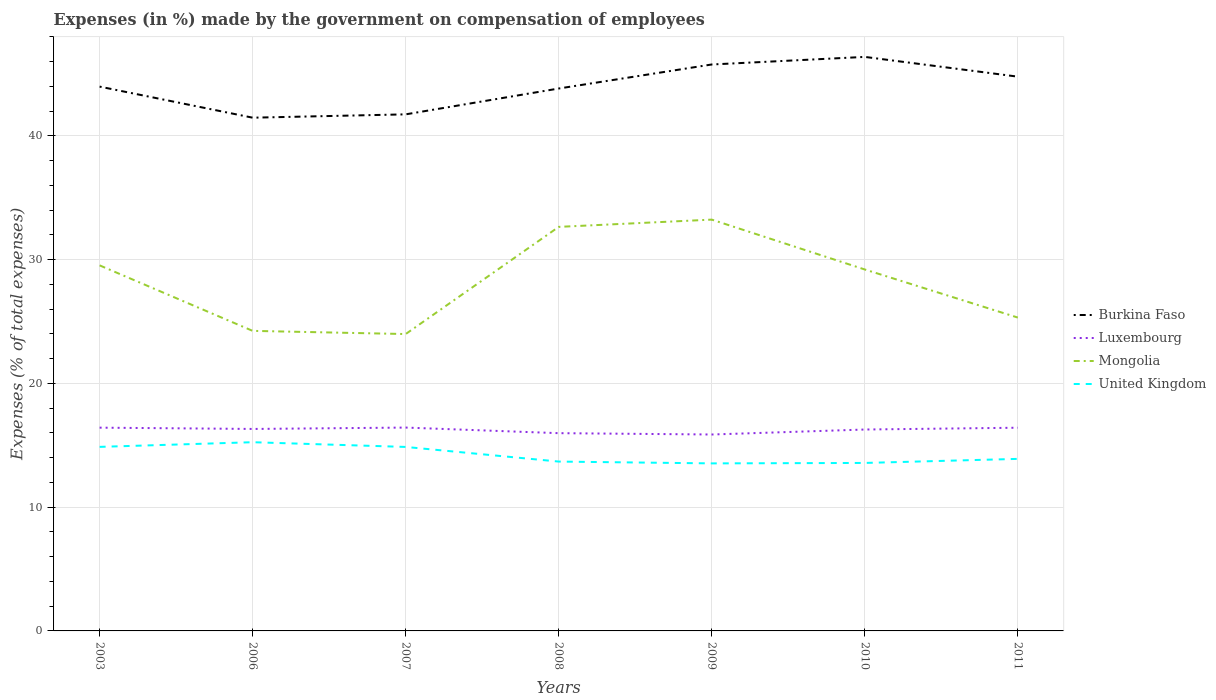How many different coloured lines are there?
Offer a terse response. 4. Across all years, what is the maximum percentage of expenses made by the government on compensation of employees in Burkina Faso?
Provide a short and direct response. 41.47. In which year was the percentage of expenses made by the government on compensation of employees in United Kingdom maximum?
Give a very brief answer. 2009. What is the total percentage of expenses made by the government on compensation of employees in Mongolia in the graph?
Your answer should be very brief. -8.66. What is the difference between the highest and the second highest percentage of expenses made by the government on compensation of employees in Luxembourg?
Your response must be concise. 0.56. What is the difference between the highest and the lowest percentage of expenses made by the government on compensation of employees in United Kingdom?
Provide a succinct answer. 3. Is the percentage of expenses made by the government on compensation of employees in Luxembourg strictly greater than the percentage of expenses made by the government on compensation of employees in Burkina Faso over the years?
Provide a succinct answer. Yes. How many lines are there?
Give a very brief answer. 4. Does the graph contain any zero values?
Provide a short and direct response. No. Where does the legend appear in the graph?
Your answer should be compact. Center right. How are the legend labels stacked?
Your response must be concise. Vertical. What is the title of the graph?
Make the answer very short. Expenses (in %) made by the government on compensation of employees. Does "Lesotho" appear as one of the legend labels in the graph?
Ensure brevity in your answer.  No. What is the label or title of the X-axis?
Your response must be concise. Years. What is the label or title of the Y-axis?
Your answer should be compact. Expenses (% of total expenses). What is the Expenses (% of total expenses) of Burkina Faso in 2003?
Make the answer very short. 43.98. What is the Expenses (% of total expenses) in Luxembourg in 2003?
Offer a very short reply. 16.42. What is the Expenses (% of total expenses) of Mongolia in 2003?
Ensure brevity in your answer.  29.54. What is the Expenses (% of total expenses) of United Kingdom in 2003?
Provide a succinct answer. 14.87. What is the Expenses (% of total expenses) of Burkina Faso in 2006?
Your response must be concise. 41.47. What is the Expenses (% of total expenses) of Luxembourg in 2006?
Make the answer very short. 16.32. What is the Expenses (% of total expenses) in Mongolia in 2006?
Your answer should be very brief. 24.25. What is the Expenses (% of total expenses) in United Kingdom in 2006?
Keep it short and to the point. 15.25. What is the Expenses (% of total expenses) in Burkina Faso in 2007?
Offer a very short reply. 41.74. What is the Expenses (% of total expenses) in Luxembourg in 2007?
Ensure brevity in your answer.  16.43. What is the Expenses (% of total expenses) in Mongolia in 2007?
Provide a short and direct response. 23.99. What is the Expenses (% of total expenses) in United Kingdom in 2007?
Offer a very short reply. 14.87. What is the Expenses (% of total expenses) of Burkina Faso in 2008?
Your answer should be compact. 43.83. What is the Expenses (% of total expenses) in Luxembourg in 2008?
Provide a succinct answer. 15.98. What is the Expenses (% of total expenses) in Mongolia in 2008?
Offer a very short reply. 32.65. What is the Expenses (% of total expenses) of United Kingdom in 2008?
Your answer should be very brief. 13.68. What is the Expenses (% of total expenses) in Burkina Faso in 2009?
Offer a terse response. 45.77. What is the Expenses (% of total expenses) in Luxembourg in 2009?
Your answer should be very brief. 15.87. What is the Expenses (% of total expenses) of Mongolia in 2009?
Your answer should be very brief. 33.24. What is the Expenses (% of total expenses) of United Kingdom in 2009?
Provide a short and direct response. 13.54. What is the Expenses (% of total expenses) in Burkina Faso in 2010?
Provide a short and direct response. 46.38. What is the Expenses (% of total expenses) of Luxembourg in 2010?
Your response must be concise. 16.27. What is the Expenses (% of total expenses) in Mongolia in 2010?
Offer a terse response. 29.21. What is the Expenses (% of total expenses) in United Kingdom in 2010?
Make the answer very short. 13.57. What is the Expenses (% of total expenses) of Burkina Faso in 2011?
Give a very brief answer. 44.79. What is the Expenses (% of total expenses) in Luxembourg in 2011?
Ensure brevity in your answer.  16.42. What is the Expenses (% of total expenses) in Mongolia in 2011?
Make the answer very short. 25.32. What is the Expenses (% of total expenses) in United Kingdom in 2011?
Give a very brief answer. 13.9. Across all years, what is the maximum Expenses (% of total expenses) of Burkina Faso?
Ensure brevity in your answer.  46.38. Across all years, what is the maximum Expenses (% of total expenses) of Luxembourg?
Keep it short and to the point. 16.43. Across all years, what is the maximum Expenses (% of total expenses) of Mongolia?
Your answer should be compact. 33.24. Across all years, what is the maximum Expenses (% of total expenses) in United Kingdom?
Keep it short and to the point. 15.25. Across all years, what is the minimum Expenses (% of total expenses) of Burkina Faso?
Your response must be concise. 41.47. Across all years, what is the minimum Expenses (% of total expenses) of Luxembourg?
Your answer should be very brief. 15.87. Across all years, what is the minimum Expenses (% of total expenses) in Mongolia?
Your response must be concise. 23.99. Across all years, what is the minimum Expenses (% of total expenses) of United Kingdom?
Offer a very short reply. 13.54. What is the total Expenses (% of total expenses) in Burkina Faso in the graph?
Make the answer very short. 307.97. What is the total Expenses (% of total expenses) of Luxembourg in the graph?
Ensure brevity in your answer.  113.72. What is the total Expenses (% of total expenses) in Mongolia in the graph?
Give a very brief answer. 198.19. What is the total Expenses (% of total expenses) in United Kingdom in the graph?
Make the answer very short. 99.69. What is the difference between the Expenses (% of total expenses) in Burkina Faso in 2003 and that in 2006?
Provide a succinct answer. 2.51. What is the difference between the Expenses (% of total expenses) in Luxembourg in 2003 and that in 2006?
Offer a very short reply. 0.1. What is the difference between the Expenses (% of total expenses) of Mongolia in 2003 and that in 2006?
Offer a very short reply. 5.29. What is the difference between the Expenses (% of total expenses) in United Kingdom in 2003 and that in 2006?
Make the answer very short. -0.38. What is the difference between the Expenses (% of total expenses) of Burkina Faso in 2003 and that in 2007?
Your answer should be very brief. 2.24. What is the difference between the Expenses (% of total expenses) in Luxembourg in 2003 and that in 2007?
Offer a terse response. -0.01. What is the difference between the Expenses (% of total expenses) in Mongolia in 2003 and that in 2007?
Give a very brief answer. 5.55. What is the difference between the Expenses (% of total expenses) in United Kingdom in 2003 and that in 2007?
Your answer should be compact. 0.01. What is the difference between the Expenses (% of total expenses) of Burkina Faso in 2003 and that in 2008?
Your answer should be very brief. 0.15. What is the difference between the Expenses (% of total expenses) in Luxembourg in 2003 and that in 2008?
Your answer should be compact. 0.45. What is the difference between the Expenses (% of total expenses) of Mongolia in 2003 and that in 2008?
Provide a succinct answer. -3.11. What is the difference between the Expenses (% of total expenses) in United Kingdom in 2003 and that in 2008?
Provide a short and direct response. 1.19. What is the difference between the Expenses (% of total expenses) in Burkina Faso in 2003 and that in 2009?
Provide a short and direct response. -1.79. What is the difference between the Expenses (% of total expenses) in Luxembourg in 2003 and that in 2009?
Offer a very short reply. 0.55. What is the difference between the Expenses (% of total expenses) in Mongolia in 2003 and that in 2009?
Your answer should be compact. -3.7. What is the difference between the Expenses (% of total expenses) in United Kingdom in 2003 and that in 2009?
Your answer should be very brief. 1.33. What is the difference between the Expenses (% of total expenses) of Burkina Faso in 2003 and that in 2010?
Your response must be concise. -2.4. What is the difference between the Expenses (% of total expenses) of Luxembourg in 2003 and that in 2010?
Provide a short and direct response. 0.15. What is the difference between the Expenses (% of total expenses) of Mongolia in 2003 and that in 2010?
Give a very brief answer. 0.33. What is the difference between the Expenses (% of total expenses) of United Kingdom in 2003 and that in 2010?
Make the answer very short. 1.3. What is the difference between the Expenses (% of total expenses) of Burkina Faso in 2003 and that in 2011?
Your answer should be compact. -0.8. What is the difference between the Expenses (% of total expenses) of Luxembourg in 2003 and that in 2011?
Your answer should be compact. 0. What is the difference between the Expenses (% of total expenses) of Mongolia in 2003 and that in 2011?
Keep it short and to the point. 4.22. What is the difference between the Expenses (% of total expenses) of United Kingdom in 2003 and that in 2011?
Ensure brevity in your answer.  0.97. What is the difference between the Expenses (% of total expenses) of Burkina Faso in 2006 and that in 2007?
Keep it short and to the point. -0.27. What is the difference between the Expenses (% of total expenses) in Luxembourg in 2006 and that in 2007?
Offer a terse response. -0.11. What is the difference between the Expenses (% of total expenses) of Mongolia in 2006 and that in 2007?
Ensure brevity in your answer.  0.26. What is the difference between the Expenses (% of total expenses) in United Kingdom in 2006 and that in 2007?
Keep it short and to the point. 0.38. What is the difference between the Expenses (% of total expenses) of Burkina Faso in 2006 and that in 2008?
Offer a terse response. -2.36. What is the difference between the Expenses (% of total expenses) of Luxembourg in 2006 and that in 2008?
Provide a short and direct response. 0.34. What is the difference between the Expenses (% of total expenses) of Mongolia in 2006 and that in 2008?
Keep it short and to the point. -8.4. What is the difference between the Expenses (% of total expenses) of United Kingdom in 2006 and that in 2008?
Offer a terse response. 1.56. What is the difference between the Expenses (% of total expenses) of Burkina Faso in 2006 and that in 2009?
Your response must be concise. -4.3. What is the difference between the Expenses (% of total expenses) in Luxembourg in 2006 and that in 2009?
Offer a terse response. 0.45. What is the difference between the Expenses (% of total expenses) of Mongolia in 2006 and that in 2009?
Make the answer very short. -8.99. What is the difference between the Expenses (% of total expenses) in United Kingdom in 2006 and that in 2009?
Provide a succinct answer. 1.71. What is the difference between the Expenses (% of total expenses) in Burkina Faso in 2006 and that in 2010?
Your answer should be very brief. -4.91. What is the difference between the Expenses (% of total expenses) of Luxembourg in 2006 and that in 2010?
Your answer should be very brief. 0.05. What is the difference between the Expenses (% of total expenses) of Mongolia in 2006 and that in 2010?
Keep it short and to the point. -4.96. What is the difference between the Expenses (% of total expenses) in United Kingdom in 2006 and that in 2010?
Your answer should be very brief. 1.67. What is the difference between the Expenses (% of total expenses) of Burkina Faso in 2006 and that in 2011?
Ensure brevity in your answer.  -3.32. What is the difference between the Expenses (% of total expenses) in Luxembourg in 2006 and that in 2011?
Your answer should be compact. -0.1. What is the difference between the Expenses (% of total expenses) in Mongolia in 2006 and that in 2011?
Keep it short and to the point. -1.07. What is the difference between the Expenses (% of total expenses) in United Kingdom in 2006 and that in 2011?
Ensure brevity in your answer.  1.35. What is the difference between the Expenses (% of total expenses) of Burkina Faso in 2007 and that in 2008?
Your response must be concise. -2.09. What is the difference between the Expenses (% of total expenses) of Luxembourg in 2007 and that in 2008?
Make the answer very short. 0.45. What is the difference between the Expenses (% of total expenses) in Mongolia in 2007 and that in 2008?
Provide a succinct answer. -8.66. What is the difference between the Expenses (% of total expenses) in United Kingdom in 2007 and that in 2008?
Provide a short and direct response. 1.18. What is the difference between the Expenses (% of total expenses) of Burkina Faso in 2007 and that in 2009?
Make the answer very short. -4.03. What is the difference between the Expenses (% of total expenses) of Luxembourg in 2007 and that in 2009?
Your answer should be very brief. 0.56. What is the difference between the Expenses (% of total expenses) in Mongolia in 2007 and that in 2009?
Make the answer very short. -9.25. What is the difference between the Expenses (% of total expenses) in United Kingdom in 2007 and that in 2009?
Offer a very short reply. 1.33. What is the difference between the Expenses (% of total expenses) in Burkina Faso in 2007 and that in 2010?
Your answer should be very brief. -4.64. What is the difference between the Expenses (% of total expenses) of Luxembourg in 2007 and that in 2010?
Your answer should be very brief. 0.16. What is the difference between the Expenses (% of total expenses) of Mongolia in 2007 and that in 2010?
Your response must be concise. -5.22. What is the difference between the Expenses (% of total expenses) of United Kingdom in 2007 and that in 2010?
Provide a succinct answer. 1.29. What is the difference between the Expenses (% of total expenses) of Burkina Faso in 2007 and that in 2011?
Your answer should be compact. -3.05. What is the difference between the Expenses (% of total expenses) of Luxembourg in 2007 and that in 2011?
Your response must be concise. 0.01. What is the difference between the Expenses (% of total expenses) in Mongolia in 2007 and that in 2011?
Keep it short and to the point. -1.33. What is the difference between the Expenses (% of total expenses) in United Kingdom in 2007 and that in 2011?
Your response must be concise. 0.97. What is the difference between the Expenses (% of total expenses) in Burkina Faso in 2008 and that in 2009?
Give a very brief answer. -1.94. What is the difference between the Expenses (% of total expenses) of Luxembourg in 2008 and that in 2009?
Ensure brevity in your answer.  0.11. What is the difference between the Expenses (% of total expenses) of Mongolia in 2008 and that in 2009?
Offer a very short reply. -0.59. What is the difference between the Expenses (% of total expenses) of United Kingdom in 2008 and that in 2009?
Ensure brevity in your answer.  0.15. What is the difference between the Expenses (% of total expenses) of Burkina Faso in 2008 and that in 2010?
Give a very brief answer. -2.55. What is the difference between the Expenses (% of total expenses) of Luxembourg in 2008 and that in 2010?
Give a very brief answer. -0.29. What is the difference between the Expenses (% of total expenses) in Mongolia in 2008 and that in 2010?
Your response must be concise. 3.44. What is the difference between the Expenses (% of total expenses) of United Kingdom in 2008 and that in 2010?
Keep it short and to the point. 0.11. What is the difference between the Expenses (% of total expenses) in Burkina Faso in 2008 and that in 2011?
Your answer should be compact. -0.96. What is the difference between the Expenses (% of total expenses) in Luxembourg in 2008 and that in 2011?
Your answer should be very brief. -0.44. What is the difference between the Expenses (% of total expenses) in Mongolia in 2008 and that in 2011?
Ensure brevity in your answer.  7.33. What is the difference between the Expenses (% of total expenses) in United Kingdom in 2008 and that in 2011?
Ensure brevity in your answer.  -0.22. What is the difference between the Expenses (% of total expenses) of Burkina Faso in 2009 and that in 2010?
Provide a succinct answer. -0.61. What is the difference between the Expenses (% of total expenses) in Luxembourg in 2009 and that in 2010?
Offer a very short reply. -0.4. What is the difference between the Expenses (% of total expenses) in Mongolia in 2009 and that in 2010?
Your answer should be very brief. 4.03. What is the difference between the Expenses (% of total expenses) in United Kingdom in 2009 and that in 2010?
Provide a short and direct response. -0.04. What is the difference between the Expenses (% of total expenses) in Burkina Faso in 2009 and that in 2011?
Give a very brief answer. 0.98. What is the difference between the Expenses (% of total expenses) in Luxembourg in 2009 and that in 2011?
Your answer should be compact. -0.55. What is the difference between the Expenses (% of total expenses) of Mongolia in 2009 and that in 2011?
Your answer should be compact. 7.92. What is the difference between the Expenses (% of total expenses) in United Kingdom in 2009 and that in 2011?
Make the answer very short. -0.36. What is the difference between the Expenses (% of total expenses) in Burkina Faso in 2010 and that in 2011?
Offer a terse response. 1.6. What is the difference between the Expenses (% of total expenses) in Luxembourg in 2010 and that in 2011?
Give a very brief answer. -0.15. What is the difference between the Expenses (% of total expenses) in Mongolia in 2010 and that in 2011?
Your answer should be compact. 3.89. What is the difference between the Expenses (% of total expenses) in United Kingdom in 2010 and that in 2011?
Provide a short and direct response. -0.33. What is the difference between the Expenses (% of total expenses) in Burkina Faso in 2003 and the Expenses (% of total expenses) in Luxembourg in 2006?
Provide a succinct answer. 27.66. What is the difference between the Expenses (% of total expenses) in Burkina Faso in 2003 and the Expenses (% of total expenses) in Mongolia in 2006?
Provide a succinct answer. 19.74. What is the difference between the Expenses (% of total expenses) of Burkina Faso in 2003 and the Expenses (% of total expenses) of United Kingdom in 2006?
Ensure brevity in your answer.  28.74. What is the difference between the Expenses (% of total expenses) of Luxembourg in 2003 and the Expenses (% of total expenses) of Mongolia in 2006?
Make the answer very short. -7.82. What is the difference between the Expenses (% of total expenses) in Luxembourg in 2003 and the Expenses (% of total expenses) in United Kingdom in 2006?
Give a very brief answer. 1.18. What is the difference between the Expenses (% of total expenses) in Mongolia in 2003 and the Expenses (% of total expenses) in United Kingdom in 2006?
Offer a terse response. 14.29. What is the difference between the Expenses (% of total expenses) of Burkina Faso in 2003 and the Expenses (% of total expenses) of Luxembourg in 2007?
Offer a very short reply. 27.55. What is the difference between the Expenses (% of total expenses) of Burkina Faso in 2003 and the Expenses (% of total expenses) of Mongolia in 2007?
Your answer should be very brief. 19.99. What is the difference between the Expenses (% of total expenses) in Burkina Faso in 2003 and the Expenses (% of total expenses) in United Kingdom in 2007?
Offer a terse response. 29.12. What is the difference between the Expenses (% of total expenses) in Luxembourg in 2003 and the Expenses (% of total expenses) in Mongolia in 2007?
Make the answer very short. -7.56. What is the difference between the Expenses (% of total expenses) of Luxembourg in 2003 and the Expenses (% of total expenses) of United Kingdom in 2007?
Offer a terse response. 1.56. What is the difference between the Expenses (% of total expenses) in Mongolia in 2003 and the Expenses (% of total expenses) in United Kingdom in 2007?
Your answer should be very brief. 14.67. What is the difference between the Expenses (% of total expenses) in Burkina Faso in 2003 and the Expenses (% of total expenses) in Luxembourg in 2008?
Make the answer very short. 28. What is the difference between the Expenses (% of total expenses) in Burkina Faso in 2003 and the Expenses (% of total expenses) in Mongolia in 2008?
Give a very brief answer. 11.33. What is the difference between the Expenses (% of total expenses) of Burkina Faso in 2003 and the Expenses (% of total expenses) of United Kingdom in 2008?
Ensure brevity in your answer.  30.3. What is the difference between the Expenses (% of total expenses) in Luxembourg in 2003 and the Expenses (% of total expenses) in Mongolia in 2008?
Provide a succinct answer. -16.22. What is the difference between the Expenses (% of total expenses) of Luxembourg in 2003 and the Expenses (% of total expenses) of United Kingdom in 2008?
Offer a terse response. 2.74. What is the difference between the Expenses (% of total expenses) of Mongolia in 2003 and the Expenses (% of total expenses) of United Kingdom in 2008?
Provide a succinct answer. 15.85. What is the difference between the Expenses (% of total expenses) of Burkina Faso in 2003 and the Expenses (% of total expenses) of Luxembourg in 2009?
Provide a short and direct response. 28.11. What is the difference between the Expenses (% of total expenses) in Burkina Faso in 2003 and the Expenses (% of total expenses) in Mongolia in 2009?
Give a very brief answer. 10.75. What is the difference between the Expenses (% of total expenses) of Burkina Faso in 2003 and the Expenses (% of total expenses) of United Kingdom in 2009?
Make the answer very short. 30.45. What is the difference between the Expenses (% of total expenses) in Luxembourg in 2003 and the Expenses (% of total expenses) in Mongolia in 2009?
Provide a succinct answer. -16.81. What is the difference between the Expenses (% of total expenses) of Luxembourg in 2003 and the Expenses (% of total expenses) of United Kingdom in 2009?
Provide a short and direct response. 2.89. What is the difference between the Expenses (% of total expenses) in Mongolia in 2003 and the Expenses (% of total expenses) in United Kingdom in 2009?
Ensure brevity in your answer.  16. What is the difference between the Expenses (% of total expenses) in Burkina Faso in 2003 and the Expenses (% of total expenses) in Luxembourg in 2010?
Your response must be concise. 27.71. What is the difference between the Expenses (% of total expenses) of Burkina Faso in 2003 and the Expenses (% of total expenses) of Mongolia in 2010?
Make the answer very short. 14.78. What is the difference between the Expenses (% of total expenses) of Burkina Faso in 2003 and the Expenses (% of total expenses) of United Kingdom in 2010?
Your response must be concise. 30.41. What is the difference between the Expenses (% of total expenses) in Luxembourg in 2003 and the Expenses (% of total expenses) in Mongolia in 2010?
Provide a short and direct response. -12.78. What is the difference between the Expenses (% of total expenses) in Luxembourg in 2003 and the Expenses (% of total expenses) in United Kingdom in 2010?
Your answer should be very brief. 2.85. What is the difference between the Expenses (% of total expenses) in Mongolia in 2003 and the Expenses (% of total expenses) in United Kingdom in 2010?
Provide a short and direct response. 15.97. What is the difference between the Expenses (% of total expenses) of Burkina Faso in 2003 and the Expenses (% of total expenses) of Luxembourg in 2011?
Your response must be concise. 27.56. What is the difference between the Expenses (% of total expenses) in Burkina Faso in 2003 and the Expenses (% of total expenses) in Mongolia in 2011?
Offer a very short reply. 18.66. What is the difference between the Expenses (% of total expenses) in Burkina Faso in 2003 and the Expenses (% of total expenses) in United Kingdom in 2011?
Offer a very short reply. 30.08. What is the difference between the Expenses (% of total expenses) of Luxembourg in 2003 and the Expenses (% of total expenses) of Mongolia in 2011?
Offer a terse response. -8.9. What is the difference between the Expenses (% of total expenses) of Luxembourg in 2003 and the Expenses (% of total expenses) of United Kingdom in 2011?
Your response must be concise. 2.52. What is the difference between the Expenses (% of total expenses) of Mongolia in 2003 and the Expenses (% of total expenses) of United Kingdom in 2011?
Your answer should be compact. 15.64. What is the difference between the Expenses (% of total expenses) of Burkina Faso in 2006 and the Expenses (% of total expenses) of Luxembourg in 2007?
Ensure brevity in your answer.  25.04. What is the difference between the Expenses (% of total expenses) of Burkina Faso in 2006 and the Expenses (% of total expenses) of Mongolia in 2007?
Make the answer very short. 17.48. What is the difference between the Expenses (% of total expenses) of Burkina Faso in 2006 and the Expenses (% of total expenses) of United Kingdom in 2007?
Offer a very short reply. 26.61. What is the difference between the Expenses (% of total expenses) in Luxembourg in 2006 and the Expenses (% of total expenses) in Mongolia in 2007?
Provide a succinct answer. -7.67. What is the difference between the Expenses (% of total expenses) in Luxembourg in 2006 and the Expenses (% of total expenses) in United Kingdom in 2007?
Offer a terse response. 1.45. What is the difference between the Expenses (% of total expenses) of Mongolia in 2006 and the Expenses (% of total expenses) of United Kingdom in 2007?
Give a very brief answer. 9.38. What is the difference between the Expenses (% of total expenses) in Burkina Faso in 2006 and the Expenses (% of total expenses) in Luxembourg in 2008?
Your response must be concise. 25.49. What is the difference between the Expenses (% of total expenses) in Burkina Faso in 2006 and the Expenses (% of total expenses) in Mongolia in 2008?
Offer a very short reply. 8.82. What is the difference between the Expenses (% of total expenses) of Burkina Faso in 2006 and the Expenses (% of total expenses) of United Kingdom in 2008?
Offer a very short reply. 27.79. What is the difference between the Expenses (% of total expenses) in Luxembourg in 2006 and the Expenses (% of total expenses) in Mongolia in 2008?
Provide a short and direct response. -16.33. What is the difference between the Expenses (% of total expenses) of Luxembourg in 2006 and the Expenses (% of total expenses) of United Kingdom in 2008?
Keep it short and to the point. 2.64. What is the difference between the Expenses (% of total expenses) of Mongolia in 2006 and the Expenses (% of total expenses) of United Kingdom in 2008?
Your answer should be compact. 10.56. What is the difference between the Expenses (% of total expenses) in Burkina Faso in 2006 and the Expenses (% of total expenses) in Luxembourg in 2009?
Make the answer very short. 25.6. What is the difference between the Expenses (% of total expenses) in Burkina Faso in 2006 and the Expenses (% of total expenses) in Mongolia in 2009?
Your answer should be very brief. 8.24. What is the difference between the Expenses (% of total expenses) of Burkina Faso in 2006 and the Expenses (% of total expenses) of United Kingdom in 2009?
Offer a terse response. 27.93. What is the difference between the Expenses (% of total expenses) in Luxembourg in 2006 and the Expenses (% of total expenses) in Mongolia in 2009?
Provide a short and direct response. -16.92. What is the difference between the Expenses (% of total expenses) in Luxembourg in 2006 and the Expenses (% of total expenses) in United Kingdom in 2009?
Provide a short and direct response. 2.78. What is the difference between the Expenses (% of total expenses) of Mongolia in 2006 and the Expenses (% of total expenses) of United Kingdom in 2009?
Your answer should be very brief. 10.71. What is the difference between the Expenses (% of total expenses) in Burkina Faso in 2006 and the Expenses (% of total expenses) in Luxembourg in 2010?
Offer a very short reply. 25.2. What is the difference between the Expenses (% of total expenses) of Burkina Faso in 2006 and the Expenses (% of total expenses) of Mongolia in 2010?
Provide a short and direct response. 12.27. What is the difference between the Expenses (% of total expenses) in Burkina Faso in 2006 and the Expenses (% of total expenses) in United Kingdom in 2010?
Keep it short and to the point. 27.9. What is the difference between the Expenses (% of total expenses) of Luxembourg in 2006 and the Expenses (% of total expenses) of Mongolia in 2010?
Give a very brief answer. -12.89. What is the difference between the Expenses (% of total expenses) of Luxembourg in 2006 and the Expenses (% of total expenses) of United Kingdom in 2010?
Your answer should be compact. 2.75. What is the difference between the Expenses (% of total expenses) in Mongolia in 2006 and the Expenses (% of total expenses) in United Kingdom in 2010?
Keep it short and to the point. 10.67. What is the difference between the Expenses (% of total expenses) in Burkina Faso in 2006 and the Expenses (% of total expenses) in Luxembourg in 2011?
Your answer should be very brief. 25.05. What is the difference between the Expenses (% of total expenses) in Burkina Faso in 2006 and the Expenses (% of total expenses) in Mongolia in 2011?
Provide a short and direct response. 16.15. What is the difference between the Expenses (% of total expenses) of Burkina Faso in 2006 and the Expenses (% of total expenses) of United Kingdom in 2011?
Give a very brief answer. 27.57. What is the difference between the Expenses (% of total expenses) of Luxembourg in 2006 and the Expenses (% of total expenses) of Mongolia in 2011?
Your response must be concise. -9. What is the difference between the Expenses (% of total expenses) of Luxembourg in 2006 and the Expenses (% of total expenses) of United Kingdom in 2011?
Give a very brief answer. 2.42. What is the difference between the Expenses (% of total expenses) in Mongolia in 2006 and the Expenses (% of total expenses) in United Kingdom in 2011?
Make the answer very short. 10.34. What is the difference between the Expenses (% of total expenses) of Burkina Faso in 2007 and the Expenses (% of total expenses) of Luxembourg in 2008?
Your response must be concise. 25.76. What is the difference between the Expenses (% of total expenses) in Burkina Faso in 2007 and the Expenses (% of total expenses) in Mongolia in 2008?
Your answer should be compact. 9.09. What is the difference between the Expenses (% of total expenses) of Burkina Faso in 2007 and the Expenses (% of total expenses) of United Kingdom in 2008?
Your answer should be very brief. 28.06. What is the difference between the Expenses (% of total expenses) in Luxembourg in 2007 and the Expenses (% of total expenses) in Mongolia in 2008?
Give a very brief answer. -16.22. What is the difference between the Expenses (% of total expenses) in Luxembourg in 2007 and the Expenses (% of total expenses) in United Kingdom in 2008?
Your response must be concise. 2.75. What is the difference between the Expenses (% of total expenses) in Mongolia in 2007 and the Expenses (% of total expenses) in United Kingdom in 2008?
Your answer should be compact. 10.3. What is the difference between the Expenses (% of total expenses) in Burkina Faso in 2007 and the Expenses (% of total expenses) in Luxembourg in 2009?
Ensure brevity in your answer.  25.87. What is the difference between the Expenses (% of total expenses) in Burkina Faso in 2007 and the Expenses (% of total expenses) in Mongolia in 2009?
Offer a very short reply. 8.51. What is the difference between the Expenses (% of total expenses) in Burkina Faso in 2007 and the Expenses (% of total expenses) in United Kingdom in 2009?
Your response must be concise. 28.2. What is the difference between the Expenses (% of total expenses) in Luxembourg in 2007 and the Expenses (% of total expenses) in Mongolia in 2009?
Your answer should be very brief. -16.8. What is the difference between the Expenses (% of total expenses) of Luxembourg in 2007 and the Expenses (% of total expenses) of United Kingdom in 2009?
Offer a very short reply. 2.89. What is the difference between the Expenses (% of total expenses) in Mongolia in 2007 and the Expenses (% of total expenses) in United Kingdom in 2009?
Give a very brief answer. 10.45. What is the difference between the Expenses (% of total expenses) of Burkina Faso in 2007 and the Expenses (% of total expenses) of Luxembourg in 2010?
Offer a terse response. 25.47. What is the difference between the Expenses (% of total expenses) in Burkina Faso in 2007 and the Expenses (% of total expenses) in Mongolia in 2010?
Your answer should be very brief. 12.54. What is the difference between the Expenses (% of total expenses) in Burkina Faso in 2007 and the Expenses (% of total expenses) in United Kingdom in 2010?
Ensure brevity in your answer.  28.17. What is the difference between the Expenses (% of total expenses) in Luxembourg in 2007 and the Expenses (% of total expenses) in Mongolia in 2010?
Ensure brevity in your answer.  -12.77. What is the difference between the Expenses (% of total expenses) in Luxembourg in 2007 and the Expenses (% of total expenses) in United Kingdom in 2010?
Give a very brief answer. 2.86. What is the difference between the Expenses (% of total expenses) of Mongolia in 2007 and the Expenses (% of total expenses) of United Kingdom in 2010?
Give a very brief answer. 10.42. What is the difference between the Expenses (% of total expenses) of Burkina Faso in 2007 and the Expenses (% of total expenses) of Luxembourg in 2011?
Ensure brevity in your answer.  25.32. What is the difference between the Expenses (% of total expenses) in Burkina Faso in 2007 and the Expenses (% of total expenses) in Mongolia in 2011?
Your answer should be very brief. 16.42. What is the difference between the Expenses (% of total expenses) of Burkina Faso in 2007 and the Expenses (% of total expenses) of United Kingdom in 2011?
Your answer should be very brief. 27.84. What is the difference between the Expenses (% of total expenses) of Luxembourg in 2007 and the Expenses (% of total expenses) of Mongolia in 2011?
Make the answer very short. -8.89. What is the difference between the Expenses (% of total expenses) in Luxembourg in 2007 and the Expenses (% of total expenses) in United Kingdom in 2011?
Offer a terse response. 2.53. What is the difference between the Expenses (% of total expenses) in Mongolia in 2007 and the Expenses (% of total expenses) in United Kingdom in 2011?
Your response must be concise. 10.09. What is the difference between the Expenses (% of total expenses) in Burkina Faso in 2008 and the Expenses (% of total expenses) in Luxembourg in 2009?
Offer a very short reply. 27.96. What is the difference between the Expenses (% of total expenses) of Burkina Faso in 2008 and the Expenses (% of total expenses) of Mongolia in 2009?
Give a very brief answer. 10.59. What is the difference between the Expenses (% of total expenses) of Burkina Faso in 2008 and the Expenses (% of total expenses) of United Kingdom in 2009?
Offer a very short reply. 30.29. What is the difference between the Expenses (% of total expenses) in Luxembourg in 2008 and the Expenses (% of total expenses) in Mongolia in 2009?
Keep it short and to the point. -17.26. What is the difference between the Expenses (% of total expenses) in Luxembourg in 2008 and the Expenses (% of total expenses) in United Kingdom in 2009?
Your answer should be compact. 2.44. What is the difference between the Expenses (% of total expenses) in Mongolia in 2008 and the Expenses (% of total expenses) in United Kingdom in 2009?
Offer a terse response. 19.11. What is the difference between the Expenses (% of total expenses) of Burkina Faso in 2008 and the Expenses (% of total expenses) of Luxembourg in 2010?
Provide a short and direct response. 27.56. What is the difference between the Expenses (% of total expenses) of Burkina Faso in 2008 and the Expenses (% of total expenses) of Mongolia in 2010?
Keep it short and to the point. 14.62. What is the difference between the Expenses (% of total expenses) of Burkina Faso in 2008 and the Expenses (% of total expenses) of United Kingdom in 2010?
Make the answer very short. 30.26. What is the difference between the Expenses (% of total expenses) in Luxembourg in 2008 and the Expenses (% of total expenses) in Mongolia in 2010?
Make the answer very short. -13.23. What is the difference between the Expenses (% of total expenses) in Luxembourg in 2008 and the Expenses (% of total expenses) in United Kingdom in 2010?
Your answer should be very brief. 2.41. What is the difference between the Expenses (% of total expenses) in Mongolia in 2008 and the Expenses (% of total expenses) in United Kingdom in 2010?
Ensure brevity in your answer.  19.08. What is the difference between the Expenses (% of total expenses) of Burkina Faso in 2008 and the Expenses (% of total expenses) of Luxembourg in 2011?
Give a very brief answer. 27.41. What is the difference between the Expenses (% of total expenses) in Burkina Faso in 2008 and the Expenses (% of total expenses) in Mongolia in 2011?
Ensure brevity in your answer.  18.51. What is the difference between the Expenses (% of total expenses) in Burkina Faso in 2008 and the Expenses (% of total expenses) in United Kingdom in 2011?
Your response must be concise. 29.93. What is the difference between the Expenses (% of total expenses) of Luxembourg in 2008 and the Expenses (% of total expenses) of Mongolia in 2011?
Your answer should be compact. -9.34. What is the difference between the Expenses (% of total expenses) in Luxembourg in 2008 and the Expenses (% of total expenses) in United Kingdom in 2011?
Your response must be concise. 2.08. What is the difference between the Expenses (% of total expenses) in Mongolia in 2008 and the Expenses (% of total expenses) in United Kingdom in 2011?
Keep it short and to the point. 18.75. What is the difference between the Expenses (% of total expenses) in Burkina Faso in 2009 and the Expenses (% of total expenses) in Luxembourg in 2010?
Make the answer very short. 29.5. What is the difference between the Expenses (% of total expenses) of Burkina Faso in 2009 and the Expenses (% of total expenses) of Mongolia in 2010?
Your response must be concise. 16.57. What is the difference between the Expenses (% of total expenses) in Burkina Faso in 2009 and the Expenses (% of total expenses) in United Kingdom in 2010?
Make the answer very short. 32.2. What is the difference between the Expenses (% of total expenses) in Luxembourg in 2009 and the Expenses (% of total expenses) in Mongolia in 2010?
Your answer should be compact. -13.33. What is the difference between the Expenses (% of total expenses) in Luxembourg in 2009 and the Expenses (% of total expenses) in United Kingdom in 2010?
Ensure brevity in your answer.  2.3. What is the difference between the Expenses (% of total expenses) in Mongolia in 2009 and the Expenses (% of total expenses) in United Kingdom in 2010?
Offer a very short reply. 19.66. What is the difference between the Expenses (% of total expenses) in Burkina Faso in 2009 and the Expenses (% of total expenses) in Luxembourg in 2011?
Make the answer very short. 29.35. What is the difference between the Expenses (% of total expenses) of Burkina Faso in 2009 and the Expenses (% of total expenses) of Mongolia in 2011?
Offer a terse response. 20.45. What is the difference between the Expenses (% of total expenses) of Burkina Faso in 2009 and the Expenses (% of total expenses) of United Kingdom in 2011?
Your answer should be very brief. 31.87. What is the difference between the Expenses (% of total expenses) in Luxembourg in 2009 and the Expenses (% of total expenses) in Mongolia in 2011?
Offer a terse response. -9.45. What is the difference between the Expenses (% of total expenses) in Luxembourg in 2009 and the Expenses (% of total expenses) in United Kingdom in 2011?
Offer a very short reply. 1.97. What is the difference between the Expenses (% of total expenses) in Mongolia in 2009 and the Expenses (% of total expenses) in United Kingdom in 2011?
Give a very brief answer. 19.33. What is the difference between the Expenses (% of total expenses) in Burkina Faso in 2010 and the Expenses (% of total expenses) in Luxembourg in 2011?
Your response must be concise. 29.96. What is the difference between the Expenses (% of total expenses) in Burkina Faso in 2010 and the Expenses (% of total expenses) in Mongolia in 2011?
Give a very brief answer. 21.06. What is the difference between the Expenses (% of total expenses) of Burkina Faso in 2010 and the Expenses (% of total expenses) of United Kingdom in 2011?
Offer a terse response. 32.48. What is the difference between the Expenses (% of total expenses) of Luxembourg in 2010 and the Expenses (% of total expenses) of Mongolia in 2011?
Keep it short and to the point. -9.05. What is the difference between the Expenses (% of total expenses) of Luxembourg in 2010 and the Expenses (% of total expenses) of United Kingdom in 2011?
Provide a succinct answer. 2.37. What is the difference between the Expenses (% of total expenses) in Mongolia in 2010 and the Expenses (% of total expenses) in United Kingdom in 2011?
Your answer should be compact. 15.3. What is the average Expenses (% of total expenses) of Burkina Faso per year?
Provide a succinct answer. 44. What is the average Expenses (% of total expenses) of Luxembourg per year?
Your answer should be compact. 16.25. What is the average Expenses (% of total expenses) of Mongolia per year?
Your answer should be very brief. 28.31. What is the average Expenses (% of total expenses) in United Kingdom per year?
Offer a very short reply. 14.24. In the year 2003, what is the difference between the Expenses (% of total expenses) of Burkina Faso and Expenses (% of total expenses) of Luxembourg?
Provide a short and direct response. 27.56. In the year 2003, what is the difference between the Expenses (% of total expenses) of Burkina Faso and Expenses (% of total expenses) of Mongolia?
Make the answer very short. 14.44. In the year 2003, what is the difference between the Expenses (% of total expenses) in Burkina Faso and Expenses (% of total expenses) in United Kingdom?
Provide a short and direct response. 29.11. In the year 2003, what is the difference between the Expenses (% of total expenses) in Luxembourg and Expenses (% of total expenses) in Mongolia?
Provide a succinct answer. -13.11. In the year 2003, what is the difference between the Expenses (% of total expenses) in Luxembourg and Expenses (% of total expenses) in United Kingdom?
Your answer should be compact. 1.55. In the year 2003, what is the difference between the Expenses (% of total expenses) of Mongolia and Expenses (% of total expenses) of United Kingdom?
Your response must be concise. 14.67. In the year 2006, what is the difference between the Expenses (% of total expenses) of Burkina Faso and Expenses (% of total expenses) of Luxembourg?
Offer a very short reply. 25.15. In the year 2006, what is the difference between the Expenses (% of total expenses) in Burkina Faso and Expenses (% of total expenses) in Mongolia?
Offer a very short reply. 17.23. In the year 2006, what is the difference between the Expenses (% of total expenses) of Burkina Faso and Expenses (% of total expenses) of United Kingdom?
Offer a terse response. 26.22. In the year 2006, what is the difference between the Expenses (% of total expenses) of Luxembourg and Expenses (% of total expenses) of Mongolia?
Your answer should be compact. -7.93. In the year 2006, what is the difference between the Expenses (% of total expenses) in Luxembourg and Expenses (% of total expenses) in United Kingdom?
Your answer should be compact. 1.07. In the year 2006, what is the difference between the Expenses (% of total expenses) in Mongolia and Expenses (% of total expenses) in United Kingdom?
Make the answer very short. 9. In the year 2007, what is the difference between the Expenses (% of total expenses) of Burkina Faso and Expenses (% of total expenses) of Luxembourg?
Provide a short and direct response. 25.31. In the year 2007, what is the difference between the Expenses (% of total expenses) in Burkina Faso and Expenses (% of total expenses) in Mongolia?
Your response must be concise. 17.75. In the year 2007, what is the difference between the Expenses (% of total expenses) in Burkina Faso and Expenses (% of total expenses) in United Kingdom?
Offer a very short reply. 26.88. In the year 2007, what is the difference between the Expenses (% of total expenses) in Luxembourg and Expenses (% of total expenses) in Mongolia?
Your answer should be very brief. -7.56. In the year 2007, what is the difference between the Expenses (% of total expenses) of Luxembourg and Expenses (% of total expenses) of United Kingdom?
Make the answer very short. 1.56. In the year 2007, what is the difference between the Expenses (% of total expenses) in Mongolia and Expenses (% of total expenses) in United Kingdom?
Your response must be concise. 9.12. In the year 2008, what is the difference between the Expenses (% of total expenses) of Burkina Faso and Expenses (% of total expenses) of Luxembourg?
Make the answer very short. 27.85. In the year 2008, what is the difference between the Expenses (% of total expenses) in Burkina Faso and Expenses (% of total expenses) in Mongolia?
Offer a very short reply. 11.18. In the year 2008, what is the difference between the Expenses (% of total expenses) of Burkina Faso and Expenses (% of total expenses) of United Kingdom?
Offer a terse response. 30.15. In the year 2008, what is the difference between the Expenses (% of total expenses) of Luxembourg and Expenses (% of total expenses) of Mongolia?
Ensure brevity in your answer.  -16.67. In the year 2008, what is the difference between the Expenses (% of total expenses) of Luxembourg and Expenses (% of total expenses) of United Kingdom?
Ensure brevity in your answer.  2.3. In the year 2008, what is the difference between the Expenses (% of total expenses) in Mongolia and Expenses (% of total expenses) in United Kingdom?
Offer a terse response. 18.96. In the year 2009, what is the difference between the Expenses (% of total expenses) in Burkina Faso and Expenses (% of total expenses) in Luxembourg?
Provide a short and direct response. 29.9. In the year 2009, what is the difference between the Expenses (% of total expenses) in Burkina Faso and Expenses (% of total expenses) in Mongolia?
Offer a terse response. 12.54. In the year 2009, what is the difference between the Expenses (% of total expenses) of Burkina Faso and Expenses (% of total expenses) of United Kingdom?
Offer a very short reply. 32.23. In the year 2009, what is the difference between the Expenses (% of total expenses) of Luxembourg and Expenses (% of total expenses) of Mongolia?
Provide a short and direct response. -17.36. In the year 2009, what is the difference between the Expenses (% of total expenses) in Luxembourg and Expenses (% of total expenses) in United Kingdom?
Give a very brief answer. 2.33. In the year 2009, what is the difference between the Expenses (% of total expenses) in Mongolia and Expenses (% of total expenses) in United Kingdom?
Ensure brevity in your answer.  19.7. In the year 2010, what is the difference between the Expenses (% of total expenses) of Burkina Faso and Expenses (% of total expenses) of Luxembourg?
Provide a succinct answer. 30.11. In the year 2010, what is the difference between the Expenses (% of total expenses) in Burkina Faso and Expenses (% of total expenses) in Mongolia?
Provide a succinct answer. 17.18. In the year 2010, what is the difference between the Expenses (% of total expenses) of Burkina Faso and Expenses (% of total expenses) of United Kingdom?
Keep it short and to the point. 32.81. In the year 2010, what is the difference between the Expenses (% of total expenses) in Luxembourg and Expenses (% of total expenses) in Mongolia?
Ensure brevity in your answer.  -12.93. In the year 2010, what is the difference between the Expenses (% of total expenses) in Luxembourg and Expenses (% of total expenses) in United Kingdom?
Give a very brief answer. 2.7. In the year 2010, what is the difference between the Expenses (% of total expenses) of Mongolia and Expenses (% of total expenses) of United Kingdom?
Make the answer very short. 15.63. In the year 2011, what is the difference between the Expenses (% of total expenses) in Burkina Faso and Expenses (% of total expenses) in Luxembourg?
Provide a short and direct response. 28.37. In the year 2011, what is the difference between the Expenses (% of total expenses) in Burkina Faso and Expenses (% of total expenses) in Mongolia?
Ensure brevity in your answer.  19.47. In the year 2011, what is the difference between the Expenses (% of total expenses) in Burkina Faso and Expenses (% of total expenses) in United Kingdom?
Offer a terse response. 30.89. In the year 2011, what is the difference between the Expenses (% of total expenses) of Luxembourg and Expenses (% of total expenses) of Mongolia?
Provide a short and direct response. -8.9. In the year 2011, what is the difference between the Expenses (% of total expenses) in Luxembourg and Expenses (% of total expenses) in United Kingdom?
Keep it short and to the point. 2.52. In the year 2011, what is the difference between the Expenses (% of total expenses) in Mongolia and Expenses (% of total expenses) in United Kingdom?
Keep it short and to the point. 11.42. What is the ratio of the Expenses (% of total expenses) in Burkina Faso in 2003 to that in 2006?
Make the answer very short. 1.06. What is the ratio of the Expenses (% of total expenses) in Luxembourg in 2003 to that in 2006?
Your response must be concise. 1.01. What is the ratio of the Expenses (% of total expenses) in Mongolia in 2003 to that in 2006?
Make the answer very short. 1.22. What is the ratio of the Expenses (% of total expenses) in United Kingdom in 2003 to that in 2006?
Make the answer very short. 0.98. What is the ratio of the Expenses (% of total expenses) in Burkina Faso in 2003 to that in 2007?
Your answer should be compact. 1.05. What is the ratio of the Expenses (% of total expenses) of Mongolia in 2003 to that in 2007?
Give a very brief answer. 1.23. What is the ratio of the Expenses (% of total expenses) in United Kingdom in 2003 to that in 2007?
Provide a short and direct response. 1. What is the ratio of the Expenses (% of total expenses) of Burkina Faso in 2003 to that in 2008?
Offer a terse response. 1. What is the ratio of the Expenses (% of total expenses) in Luxembourg in 2003 to that in 2008?
Your answer should be compact. 1.03. What is the ratio of the Expenses (% of total expenses) in Mongolia in 2003 to that in 2008?
Provide a succinct answer. 0.9. What is the ratio of the Expenses (% of total expenses) of United Kingdom in 2003 to that in 2008?
Offer a terse response. 1.09. What is the ratio of the Expenses (% of total expenses) in Burkina Faso in 2003 to that in 2009?
Provide a succinct answer. 0.96. What is the ratio of the Expenses (% of total expenses) of Luxembourg in 2003 to that in 2009?
Your answer should be compact. 1.03. What is the ratio of the Expenses (% of total expenses) of Mongolia in 2003 to that in 2009?
Give a very brief answer. 0.89. What is the ratio of the Expenses (% of total expenses) of United Kingdom in 2003 to that in 2009?
Your answer should be compact. 1.1. What is the ratio of the Expenses (% of total expenses) in Burkina Faso in 2003 to that in 2010?
Provide a short and direct response. 0.95. What is the ratio of the Expenses (% of total expenses) in Luxembourg in 2003 to that in 2010?
Keep it short and to the point. 1.01. What is the ratio of the Expenses (% of total expenses) in Mongolia in 2003 to that in 2010?
Provide a succinct answer. 1.01. What is the ratio of the Expenses (% of total expenses) of United Kingdom in 2003 to that in 2010?
Keep it short and to the point. 1.1. What is the ratio of the Expenses (% of total expenses) in Mongolia in 2003 to that in 2011?
Your answer should be compact. 1.17. What is the ratio of the Expenses (% of total expenses) of United Kingdom in 2003 to that in 2011?
Provide a short and direct response. 1.07. What is the ratio of the Expenses (% of total expenses) in Luxembourg in 2006 to that in 2007?
Keep it short and to the point. 0.99. What is the ratio of the Expenses (% of total expenses) of Mongolia in 2006 to that in 2007?
Keep it short and to the point. 1.01. What is the ratio of the Expenses (% of total expenses) of United Kingdom in 2006 to that in 2007?
Keep it short and to the point. 1.03. What is the ratio of the Expenses (% of total expenses) in Burkina Faso in 2006 to that in 2008?
Your response must be concise. 0.95. What is the ratio of the Expenses (% of total expenses) in Luxembourg in 2006 to that in 2008?
Your response must be concise. 1.02. What is the ratio of the Expenses (% of total expenses) in Mongolia in 2006 to that in 2008?
Provide a short and direct response. 0.74. What is the ratio of the Expenses (% of total expenses) of United Kingdom in 2006 to that in 2008?
Ensure brevity in your answer.  1.11. What is the ratio of the Expenses (% of total expenses) in Burkina Faso in 2006 to that in 2009?
Your answer should be compact. 0.91. What is the ratio of the Expenses (% of total expenses) in Luxembourg in 2006 to that in 2009?
Provide a short and direct response. 1.03. What is the ratio of the Expenses (% of total expenses) of Mongolia in 2006 to that in 2009?
Offer a very short reply. 0.73. What is the ratio of the Expenses (% of total expenses) of United Kingdom in 2006 to that in 2009?
Give a very brief answer. 1.13. What is the ratio of the Expenses (% of total expenses) of Burkina Faso in 2006 to that in 2010?
Ensure brevity in your answer.  0.89. What is the ratio of the Expenses (% of total expenses) of Mongolia in 2006 to that in 2010?
Offer a terse response. 0.83. What is the ratio of the Expenses (% of total expenses) of United Kingdom in 2006 to that in 2010?
Offer a terse response. 1.12. What is the ratio of the Expenses (% of total expenses) in Burkina Faso in 2006 to that in 2011?
Make the answer very short. 0.93. What is the ratio of the Expenses (% of total expenses) in Luxembourg in 2006 to that in 2011?
Make the answer very short. 0.99. What is the ratio of the Expenses (% of total expenses) of Mongolia in 2006 to that in 2011?
Ensure brevity in your answer.  0.96. What is the ratio of the Expenses (% of total expenses) of United Kingdom in 2006 to that in 2011?
Ensure brevity in your answer.  1.1. What is the ratio of the Expenses (% of total expenses) in Burkina Faso in 2007 to that in 2008?
Your answer should be very brief. 0.95. What is the ratio of the Expenses (% of total expenses) in Luxembourg in 2007 to that in 2008?
Keep it short and to the point. 1.03. What is the ratio of the Expenses (% of total expenses) of Mongolia in 2007 to that in 2008?
Your answer should be very brief. 0.73. What is the ratio of the Expenses (% of total expenses) in United Kingdom in 2007 to that in 2008?
Offer a very short reply. 1.09. What is the ratio of the Expenses (% of total expenses) in Burkina Faso in 2007 to that in 2009?
Offer a very short reply. 0.91. What is the ratio of the Expenses (% of total expenses) in Luxembourg in 2007 to that in 2009?
Offer a very short reply. 1.04. What is the ratio of the Expenses (% of total expenses) in Mongolia in 2007 to that in 2009?
Offer a terse response. 0.72. What is the ratio of the Expenses (% of total expenses) in United Kingdom in 2007 to that in 2009?
Give a very brief answer. 1.1. What is the ratio of the Expenses (% of total expenses) in Burkina Faso in 2007 to that in 2010?
Your answer should be compact. 0.9. What is the ratio of the Expenses (% of total expenses) in Luxembourg in 2007 to that in 2010?
Provide a succinct answer. 1.01. What is the ratio of the Expenses (% of total expenses) of Mongolia in 2007 to that in 2010?
Provide a succinct answer. 0.82. What is the ratio of the Expenses (% of total expenses) in United Kingdom in 2007 to that in 2010?
Ensure brevity in your answer.  1.1. What is the ratio of the Expenses (% of total expenses) of Burkina Faso in 2007 to that in 2011?
Offer a very short reply. 0.93. What is the ratio of the Expenses (% of total expenses) of Luxembourg in 2007 to that in 2011?
Provide a succinct answer. 1. What is the ratio of the Expenses (% of total expenses) in United Kingdom in 2007 to that in 2011?
Your response must be concise. 1.07. What is the ratio of the Expenses (% of total expenses) in Burkina Faso in 2008 to that in 2009?
Give a very brief answer. 0.96. What is the ratio of the Expenses (% of total expenses) in Luxembourg in 2008 to that in 2009?
Provide a short and direct response. 1.01. What is the ratio of the Expenses (% of total expenses) in Mongolia in 2008 to that in 2009?
Give a very brief answer. 0.98. What is the ratio of the Expenses (% of total expenses) of United Kingdom in 2008 to that in 2009?
Make the answer very short. 1.01. What is the ratio of the Expenses (% of total expenses) in Burkina Faso in 2008 to that in 2010?
Provide a short and direct response. 0.94. What is the ratio of the Expenses (% of total expenses) of Luxembourg in 2008 to that in 2010?
Your answer should be compact. 0.98. What is the ratio of the Expenses (% of total expenses) of Mongolia in 2008 to that in 2010?
Give a very brief answer. 1.12. What is the ratio of the Expenses (% of total expenses) of Burkina Faso in 2008 to that in 2011?
Your answer should be compact. 0.98. What is the ratio of the Expenses (% of total expenses) of Luxembourg in 2008 to that in 2011?
Ensure brevity in your answer.  0.97. What is the ratio of the Expenses (% of total expenses) of Mongolia in 2008 to that in 2011?
Keep it short and to the point. 1.29. What is the ratio of the Expenses (% of total expenses) of United Kingdom in 2008 to that in 2011?
Your response must be concise. 0.98. What is the ratio of the Expenses (% of total expenses) in Luxembourg in 2009 to that in 2010?
Ensure brevity in your answer.  0.98. What is the ratio of the Expenses (% of total expenses) in Mongolia in 2009 to that in 2010?
Provide a succinct answer. 1.14. What is the ratio of the Expenses (% of total expenses) in Luxembourg in 2009 to that in 2011?
Offer a very short reply. 0.97. What is the ratio of the Expenses (% of total expenses) of Mongolia in 2009 to that in 2011?
Make the answer very short. 1.31. What is the ratio of the Expenses (% of total expenses) in United Kingdom in 2009 to that in 2011?
Ensure brevity in your answer.  0.97. What is the ratio of the Expenses (% of total expenses) of Burkina Faso in 2010 to that in 2011?
Your answer should be compact. 1.04. What is the ratio of the Expenses (% of total expenses) in Luxembourg in 2010 to that in 2011?
Make the answer very short. 0.99. What is the ratio of the Expenses (% of total expenses) of Mongolia in 2010 to that in 2011?
Your answer should be compact. 1.15. What is the ratio of the Expenses (% of total expenses) of United Kingdom in 2010 to that in 2011?
Offer a very short reply. 0.98. What is the difference between the highest and the second highest Expenses (% of total expenses) of Burkina Faso?
Provide a short and direct response. 0.61. What is the difference between the highest and the second highest Expenses (% of total expenses) of Luxembourg?
Make the answer very short. 0.01. What is the difference between the highest and the second highest Expenses (% of total expenses) in Mongolia?
Your answer should be very brief. 0.59. What is the difference between the highest and the second highest Expenses (% of total expenses) of United Kingdom?
Offer a terse response. 0.38. What is the difference between the highest and the lowest Expenses (% of total expenses) of Burkina Faso?
Your answer should be compact. 4.91. What is the difference between the highest and the lowest Expenses (% of total expenses) in Luxembourg?
Offer a very short reply. 0.56. What is the difference between the highest and the lowest Expenses (% of total expenses) in Mongolia?
Offer a terse response. 9.25. What is the difference between the highest and the lowest Expenses (% of total expenses) of United Kingdom?
Provide a short and direct response. 1.71. 